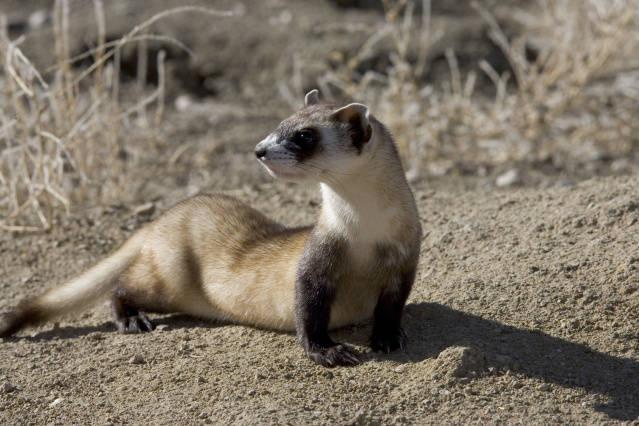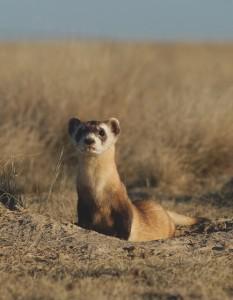The first image is the image on the left, the second image is the image on the right. Analyze the images presented: Is the assertion "there are exactly three animals in one of the images" valid? Answer yes or no. No. The first image is the image on the left, the second image is the image on the right. Assess this claim about the two images: "There are no more than 3 ferrets shown.". Correct or not? Answer yes or no. Yes. 